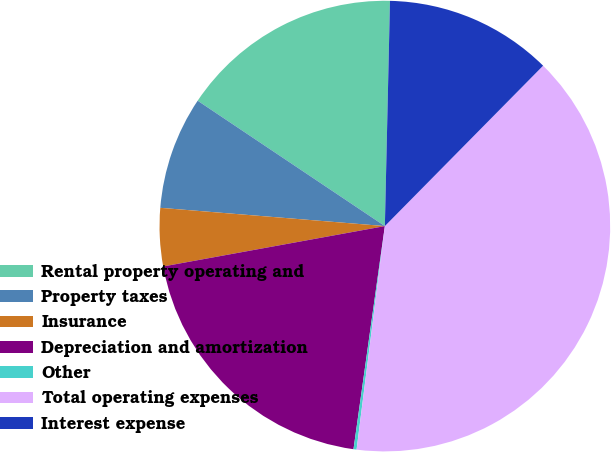<chart> <loc_0><loc_0><loc_500><loc_500><pie_chart><fcel>Rental property operating and<fcel>Property taxes<fcel>Insurance<fcel>Depreciation and amortization<fcel>Other<fcel>Total operating expenses<fcel>Interest expense<nl><fcel>15.97%<fcel>8.1%<fcel>4.16%<fcel>19.91%<fcel>0.22%<fcel>39.61%<fcel>12.03%<nl></chart> 